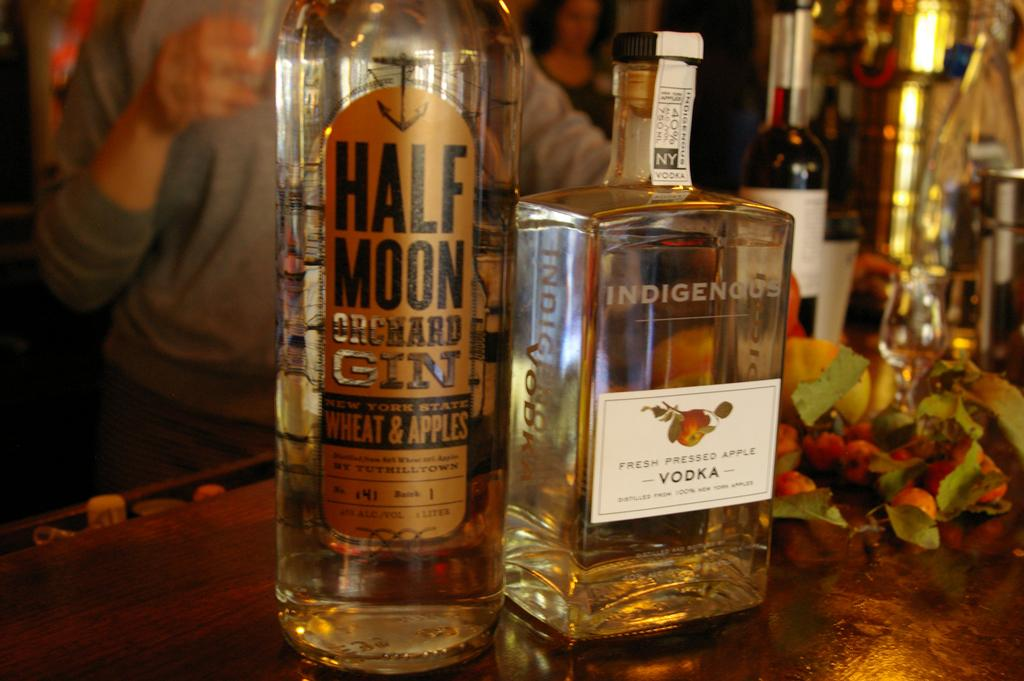<image>
Render a clear and concise summary of the photo. A bottle of gin and a bottle of vodka sit side by side on a bar. 